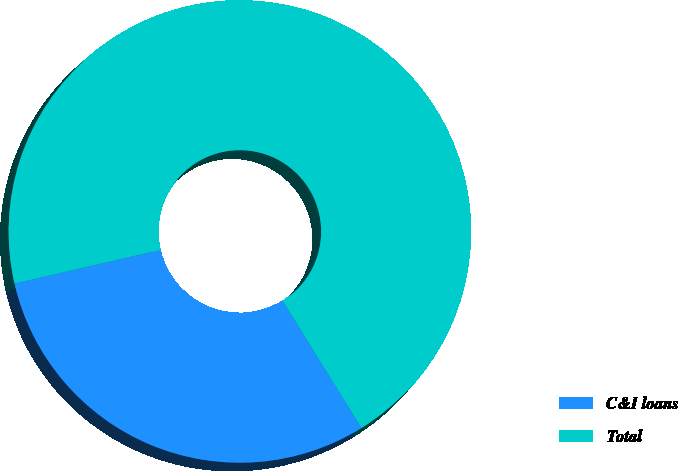Convert chart to OTSL. <chart><loc_0><loc_0><loc_500><loc_500><pie_chart><fcel>C&I loans<fcel>Total<nl><fcel>30.22%<fcel>69.78%<nl></chart> 